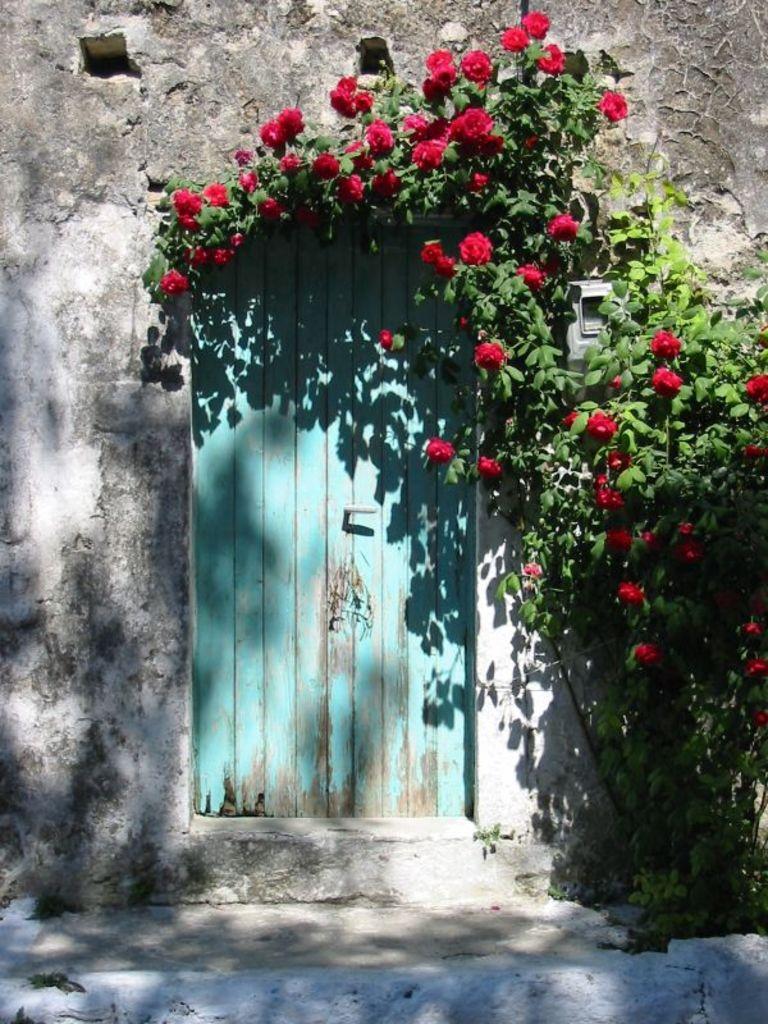Could you give a brief overview of what you see in this image? This looks like a tree with the leaves and flowers, which are red in color. I can see a wooden door with a door handle. Here is the wall. 